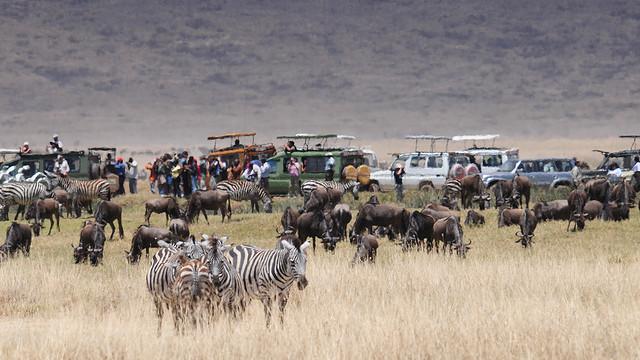What continent are these animals found on?
Concise answer only. Africa. Is the only animal in the picture a zebra?
Be succinct. No. How many vehicles are in the field?
Write a very short answer. 7. 